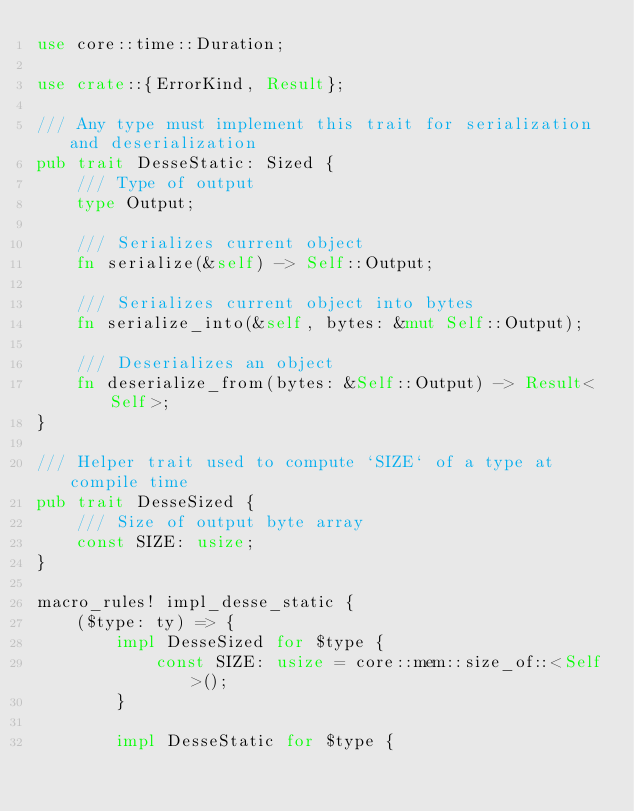Convert code to text. <code><loc_0><loc_0><loc_500><loc_500><_Rust_>use core::time::Duration;

use crate::{ErrorKind, Result};

/// Any type must implement this trait for serialization and deserialization
pub trait DesseStatic: Sized {
    /// Type of output
    type Output;

    /// Serializes current object
    fn serialize(&self) -> Self::Output;

    /// Serializes current object into bytes
    fn serialize_into(&self, bytes: &mut Self::Output);

    /// Deserializes an object
    fn deserialize_from(bytes: &Self::Output) -> Result<Self>;
}

/// Helper trait used to compute `SIZE` of a type at compile time
pub trait DesseSized {
    /// Size of output byte array
    const SIZE: usize;
}

macro_rules! impl_desse_static {
    ($type: ty) => {
        impl DesseSized for $type {
            const SIZE: usize = core::mem::size_of::<Self>();
        }

        impl DesseStatic for $type {</code> 